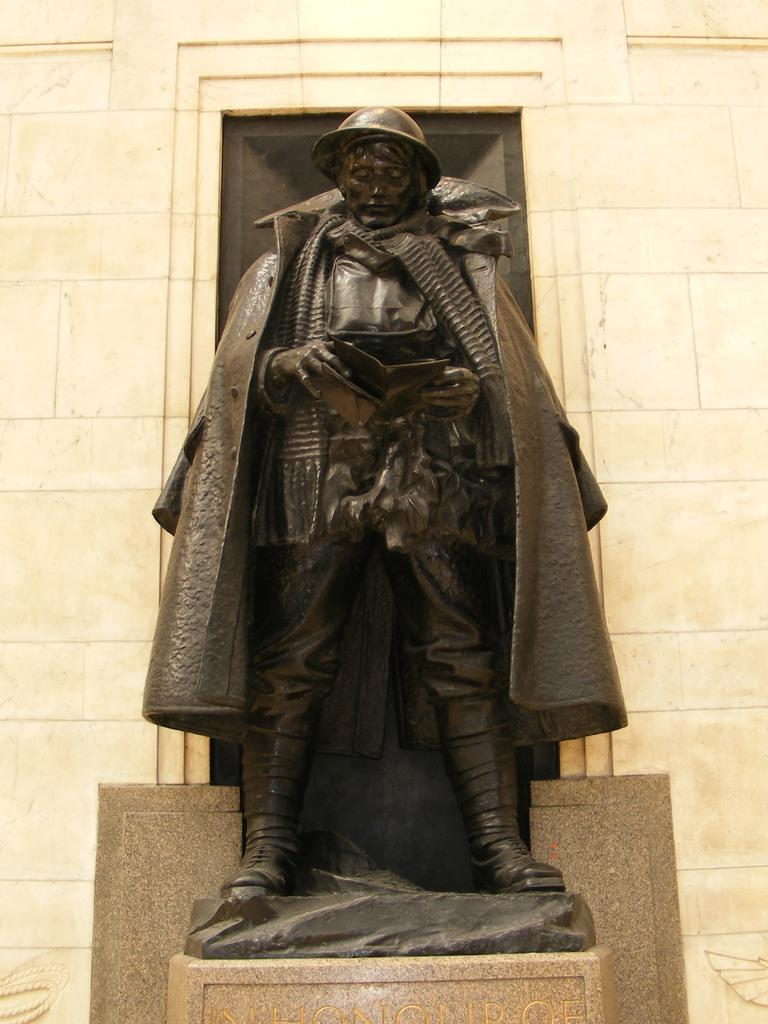What is the main subject of the image? There is a sculpture in the image. Where is the sculpture located? The sculpture is on a platform. What can be seen in the background of the image? There is a wall in the background of the image. How many children are playing with the dogs near the stranger in the image? There is no stranger, children, or dogs present in the image; it only features a sculpture on a platform with a wall in the background. 